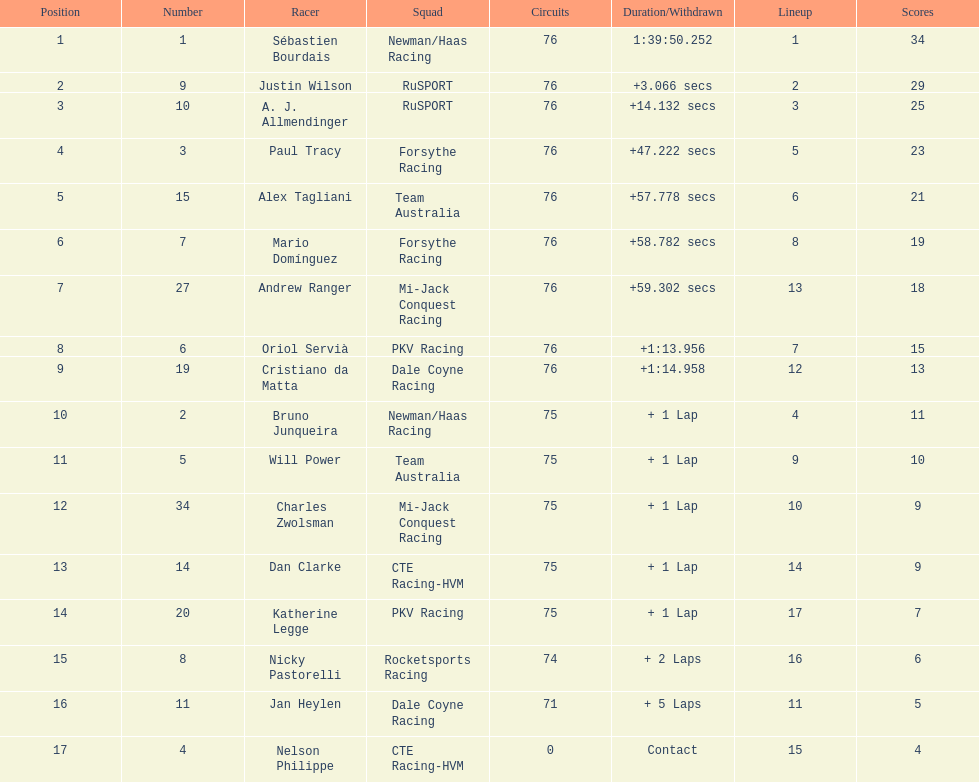Which driver has the least amount of points? Nelson Philippe. 